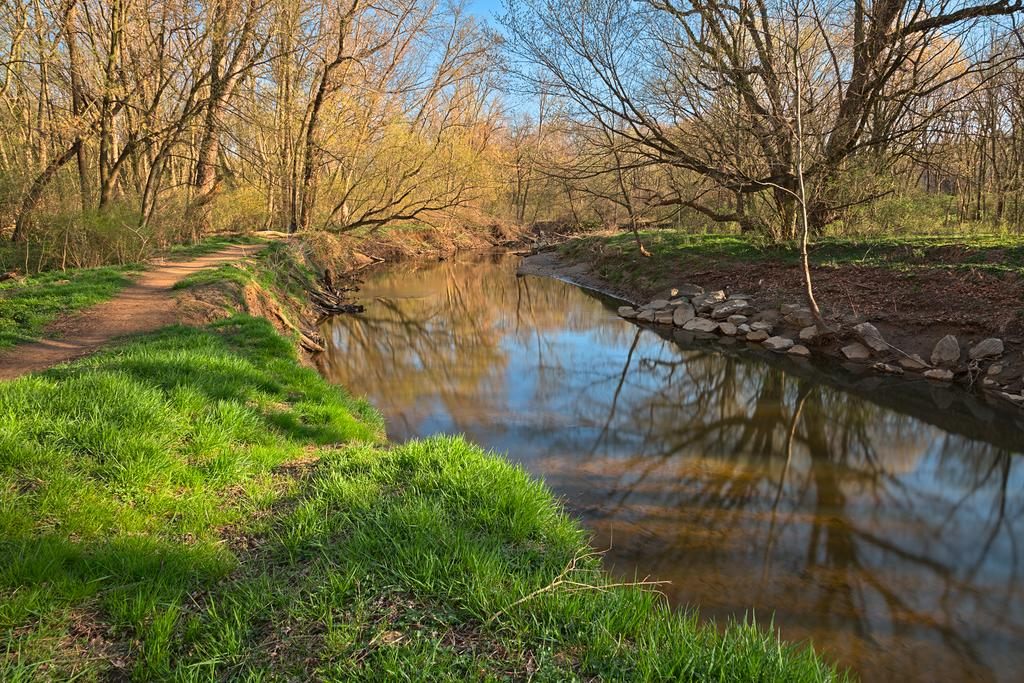What is the main feature in the center of the image? There is a canal in the center of the image. What type of vegetation is at the bottom of the image? There is grass at the bottom of the image. What can be seen in the background of the image? There are trees and rocks visible in the background of the image. What part of the natural environment is visible in the image? The sky is visible in the image. Where is the sink located in the image? There is no sink present in the image. What type of scarecrow can be seen standing among the trees in the image? There is no scarecrow present in the image; only trees and rocks are visible in the background. 